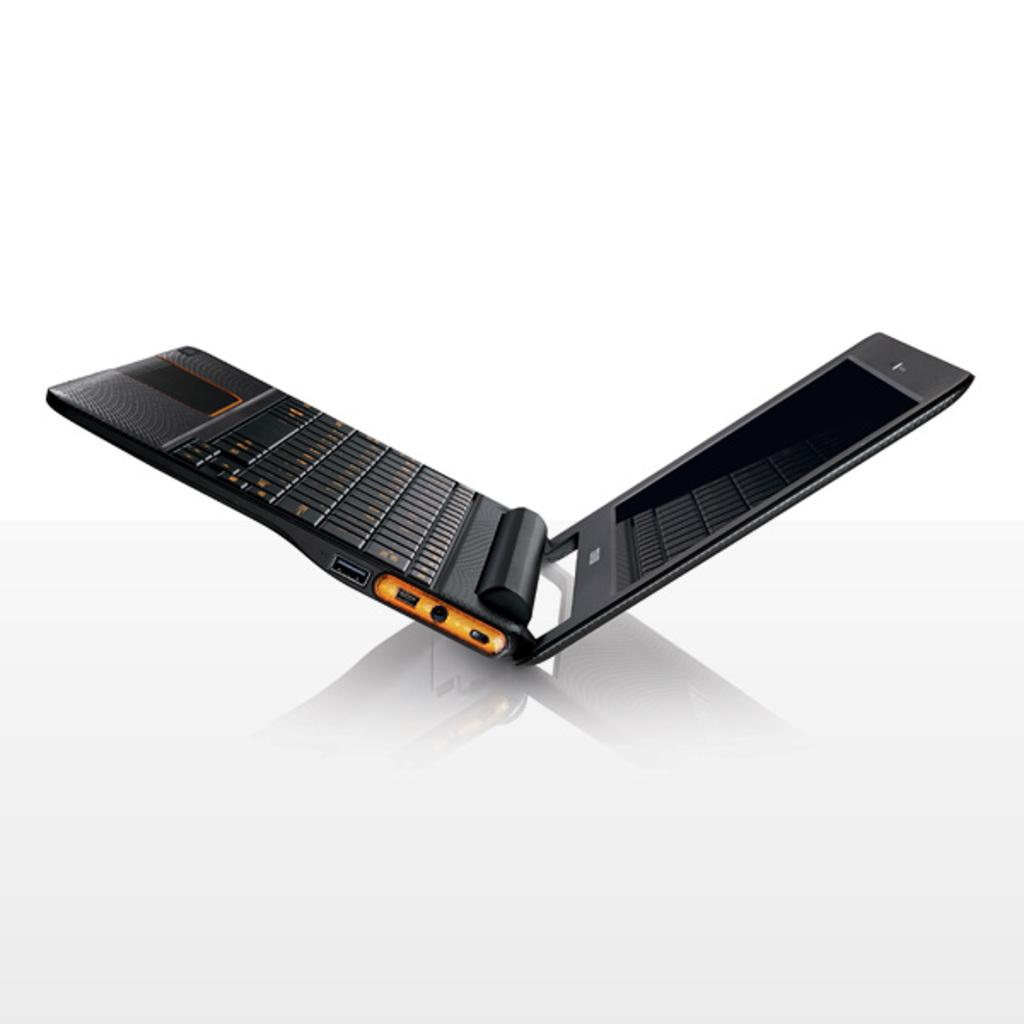What electronic device is visible in the image? There is a laptop in the image. Where is the laptop located? The laptop is placed on a surface. What type of advertisement is displayed on the umbrella in the image? There is no umbrella present in the image, and therefore no advertisement can be observed. 